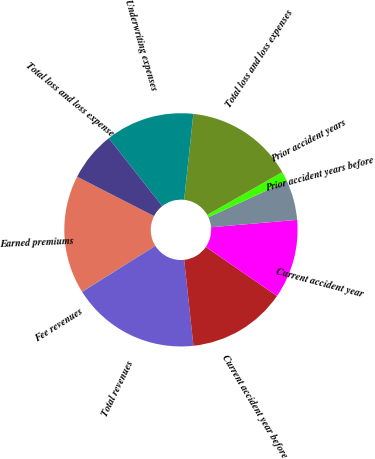Convert chart to OTSL. <chart><loc_0><loc_0><loc_500><loc_500><pie_chart><fcel>Earned premiums<fcel>Fee revenues<fcel>Total revenues<fcel>Current accident year before<fcel>Current accident year<fcel>Prior accident years before<fcel>Prior accident years<fcel>Total loss and loss expenses<fcel>Underwriting expenses<fcel>Total loss and loss expense<nl><fcel>16.43%<fcel>0.02%<fcel>17.79%<fcel>13.69%<fcel>10.96%<fcel>5.49%<fcel>1.39%<fcel>15.06%<fcel>12.32%<fcel>6.85%<nl></chart> 